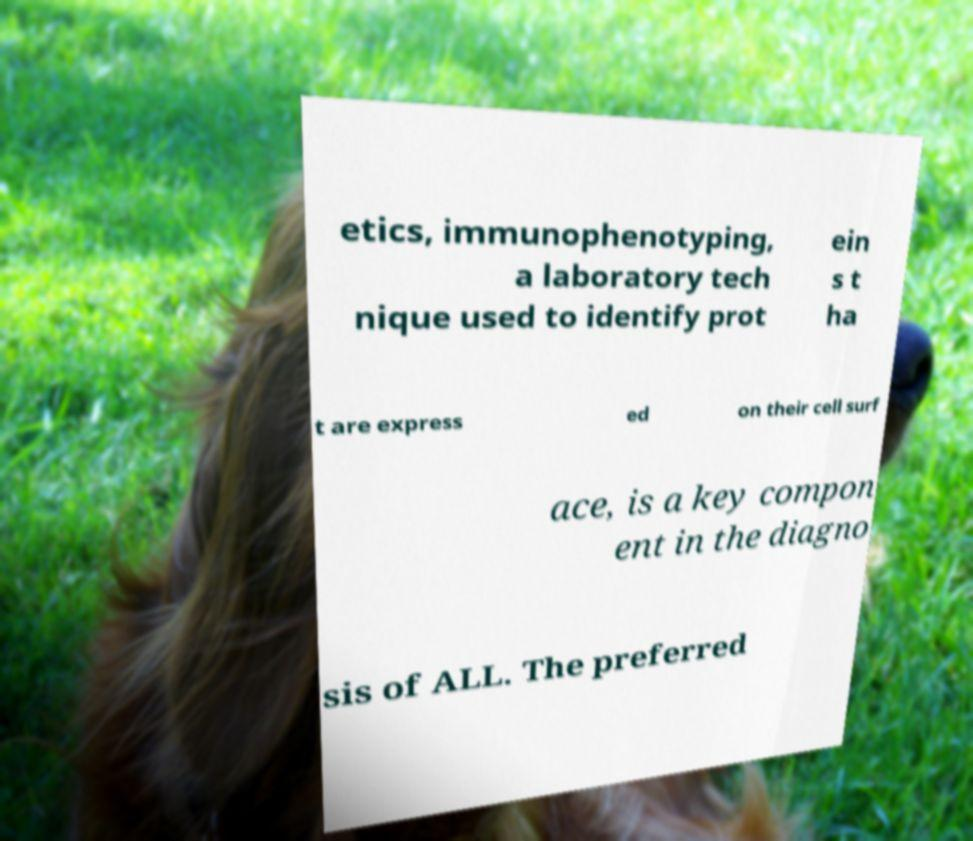Can you read and provide the text displayed in the image?This photo seems to have some interesting text. Can you extract and type it out for me? etics, immunophenotyping, a laboratory tech nique used to identify prot ein s t ha t are express ed on their cell surf ace, is a key compon ent in the diagno sis of ALL. The preferred 